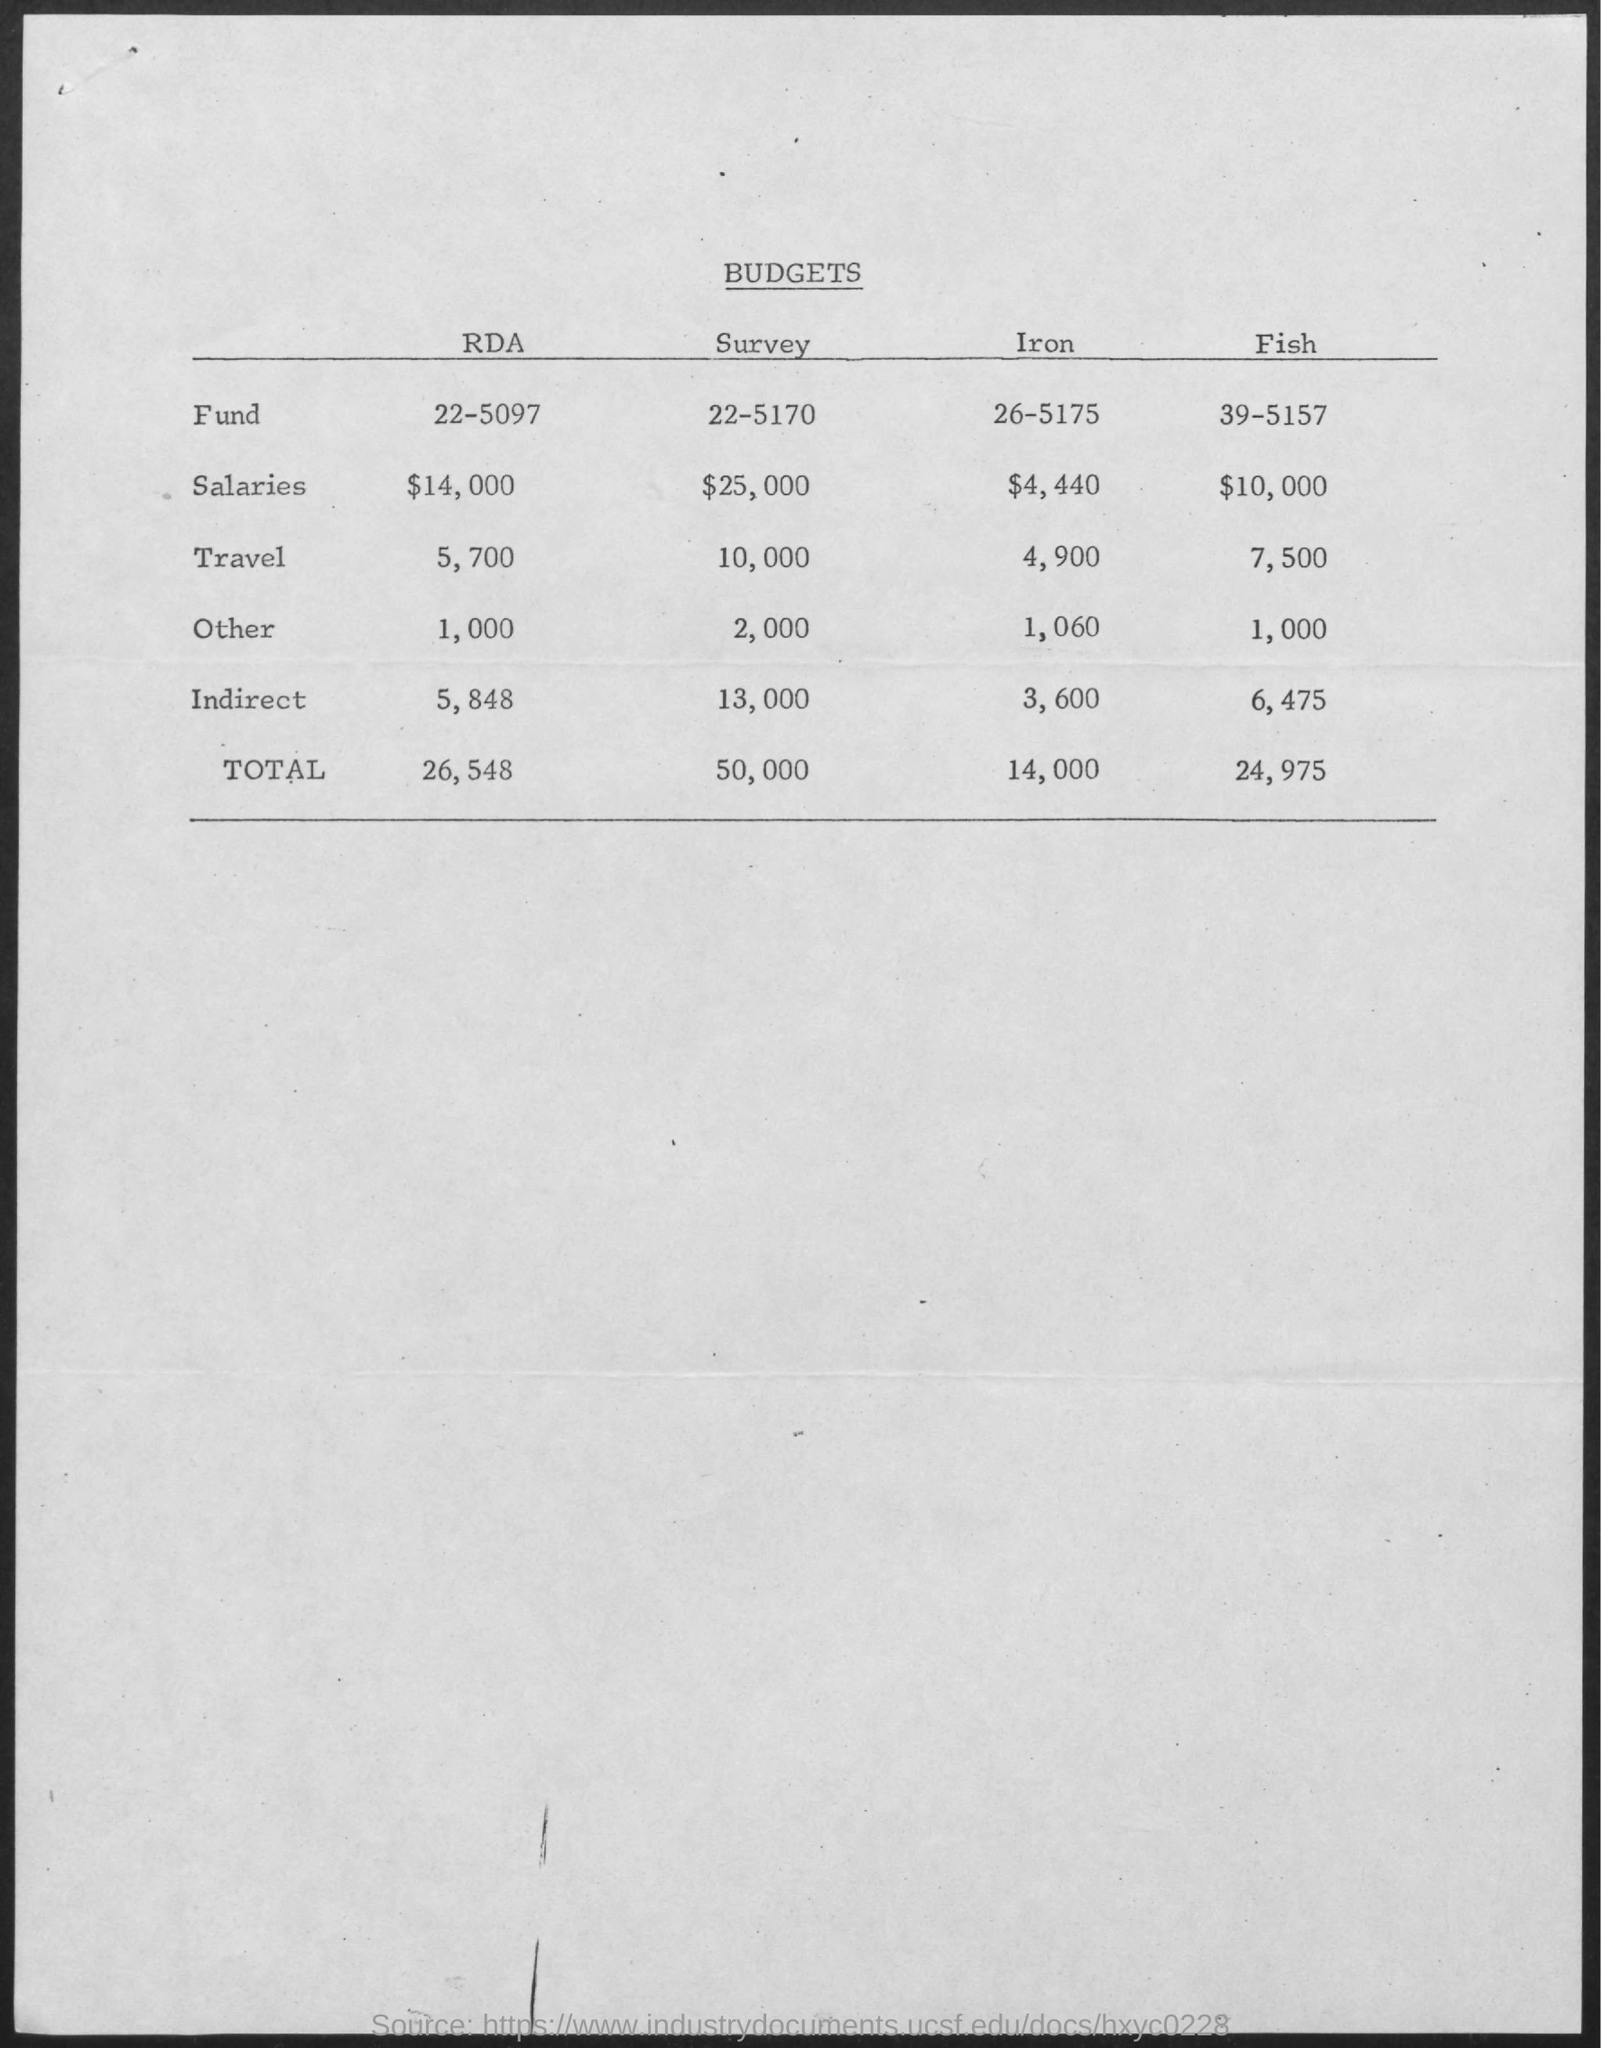Specify some key components in this picture. The budget allocated for salaries for iron is $4,440. The budget for travel expenses for the survey is $10,000. The budget for salaries for the Regional Development Australia (RDA) is $14,000. The budget allocated for salaries for fish is $10,000. The budget for the Fund for Fish is 39-5157. 